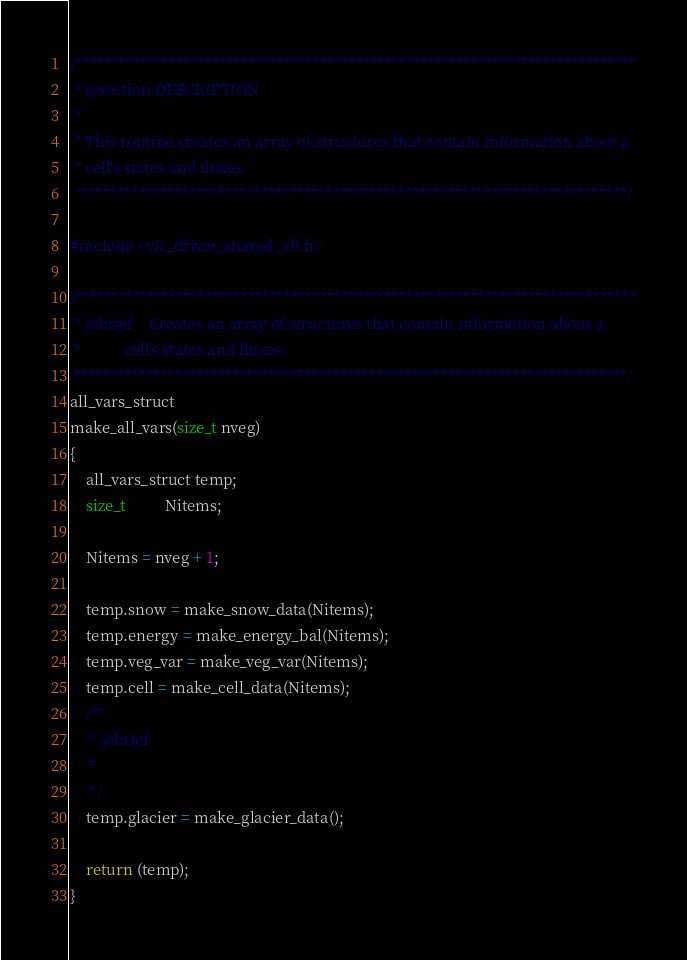Convert code to text. <code><loc_0><loc_0><loc_500><loc_500><_C_>/******************************************************************************
 * @section DESCRIPTION
 *
 * This routine creates an array of structures that contain information about a
 * cell's states and fluxes.
 *****************************************************************************/

#include <vic_driver_shared_all.h>

/******************************************************************************
 * @brief    Creates an array of structures that contain information about a
 *           cell's states and fluxes.
 *****************************************************************************/
all_vars_struct
make_all_vars(size_t nveg)
{
    all_vars_struct temp;
    size_t          Nitems;

    Nitems = nveg + 1;

    temp.snow = make_snow_data(Nitems);
    temp.energy = make_energy_bal(Nitems);
    temp.veg_var = make_veg_var(Nitems);
    temp.cell = make_cell_data(Nitems);
    /**
     * @brief 
     * 
     */
    temp.glacier = make_glacier_data();

    return (temp);
}
</code> 